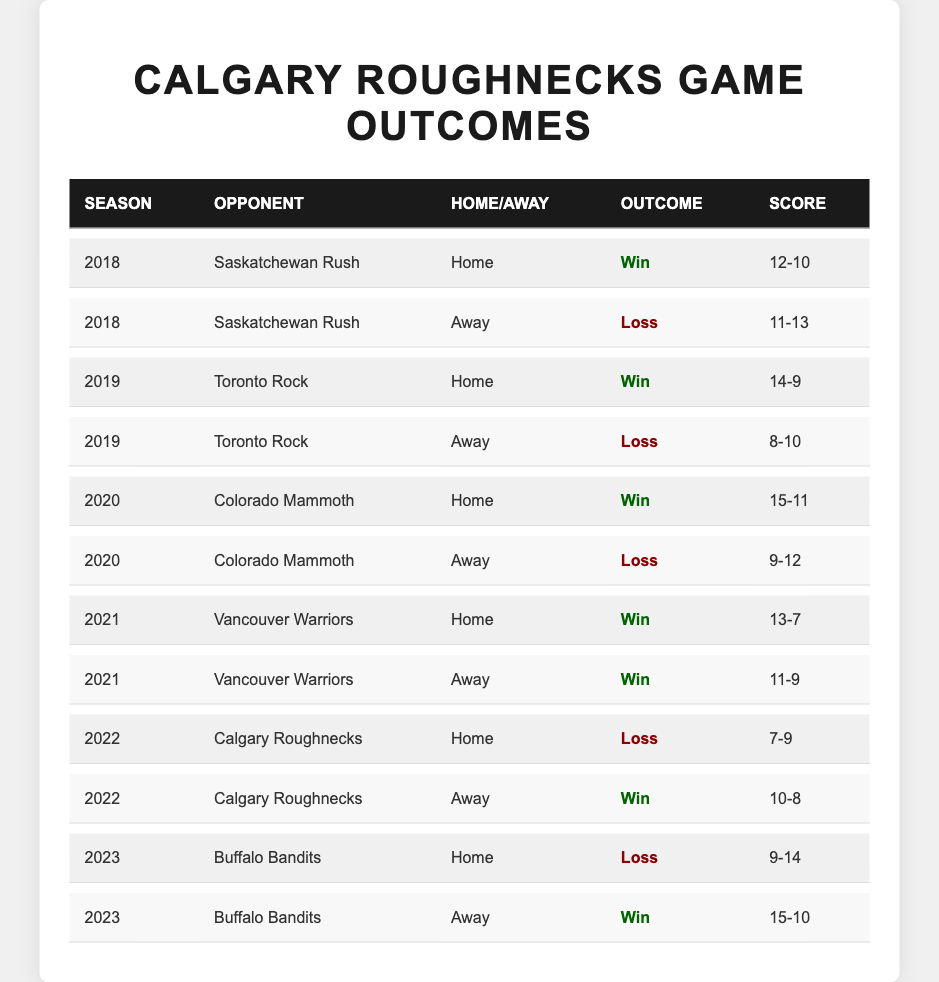What was the outcome of the Calgary Roughnecks' game against the Saskatchewan Rush at home in 2018? The table shows that in 2018, the Calgary Roughnecks played the Saskatchewan Rush at home and the outcome was a win, with a score of 12-10.
Answer: Win What was the score of the Calgary Roughnecks' away game against the Toronto Rock in 2019? The table indicates that the Calgary Roughnecks played against the Toronto Rock away in 2019 and the score was 8-10, resulting in a loss.
Answer: 8-10 How many wins did the Calgary Roughnecks secure at home during the 2021 season? By reviewing the table, the Calgary Roughnecks won two home games in 2021: against Vancouver Warriors, so the total number of home wins is 2.
Answer: 2 Did the Calgary Roughnecks win any games against the Colorado Mammoth in 2020? The table shows that the Calgary Roughnecks played the Colorado Mammoth twice in 2020; they won at home but lost away. Therefore, they did win one game.
Answer: Yes What is the total number of wins for the Calgary Roughnecks across all games listed in the table? Counting all the wins in the table, there are six wins across the seasons listed: 2018 - 1, 2019 - 1, 2020 - 1, 2021 - 2, 2022 - 1, and 2023 - 1, giving a total of 6 wins.
Answer: 6 How did the Calgary Roughnecks perform at home versus away games over the five seasons? Analyzing the table: at home, they had 4 wins (2018 vs Rush, 2019 vs Rock, 2020 vs Mammoth, 2021 vs Warriors) and 3 losses (2 in 2022, 1 in 2023). For away games, they had 2 wins (2021 vs Warriors, 2023 vs Bandits) and 4 losses (2 in 2018, 2019, 2020 against Rush and Rock). Therefore, they performed better at home with more wins compared to away.
Answer: Better at home Which team did the Calgary Roughnecks defeat in 2021 and what were the scores? The Calgary Roughnecks defeated the Vancouver Warriors in both matches in 2021 with scores of 13-7 (home) and 11-9 (away).
Answer: Vancouver Warriors, 13-7 and 11-9 Was the outcome of the Calgary Roughnecks' home game against the Buffalo Bandits in 2023 a win or a loss? Looking at the table, the outcome of the Calgary Roughnecks' home game against the Buffalo Bandits in 2023 was a loss, with a score of 9-14.
Answer: Loss How many losses did the Calgary Roughnecks have against the Saskatchewan Rush over the five seasons? The table shows that the Roughnecks lost two games against the Saskatchewan Rush; one at home in 2018 and one away in 2018, meaning they had 2 losses to this team.
Answer: 2 What is the average score when the Calgary Roughnecks played against the Vancouver Warriors in 2021? The scores against the Vancouver Warriors were 13-7 and 11-9. To find the average, add the scores of both games (13+7+11+9) which equals 40, and divide by 4 (the total quarters), resulting in an average score of 10.
Answer: 10 